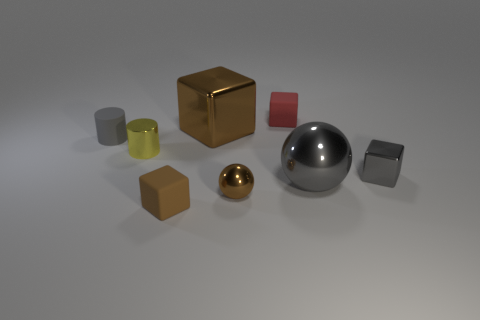Is the size of the gray metal object that is left of the gray metal cube the same as the tiny brown matte cube? The size of the gray metal object to the left of the gray metal cube is larger than the tiny brown matte cube in the image. The gray object appears to be a cylinder which is both taller and wider compared to the small brown cube. 